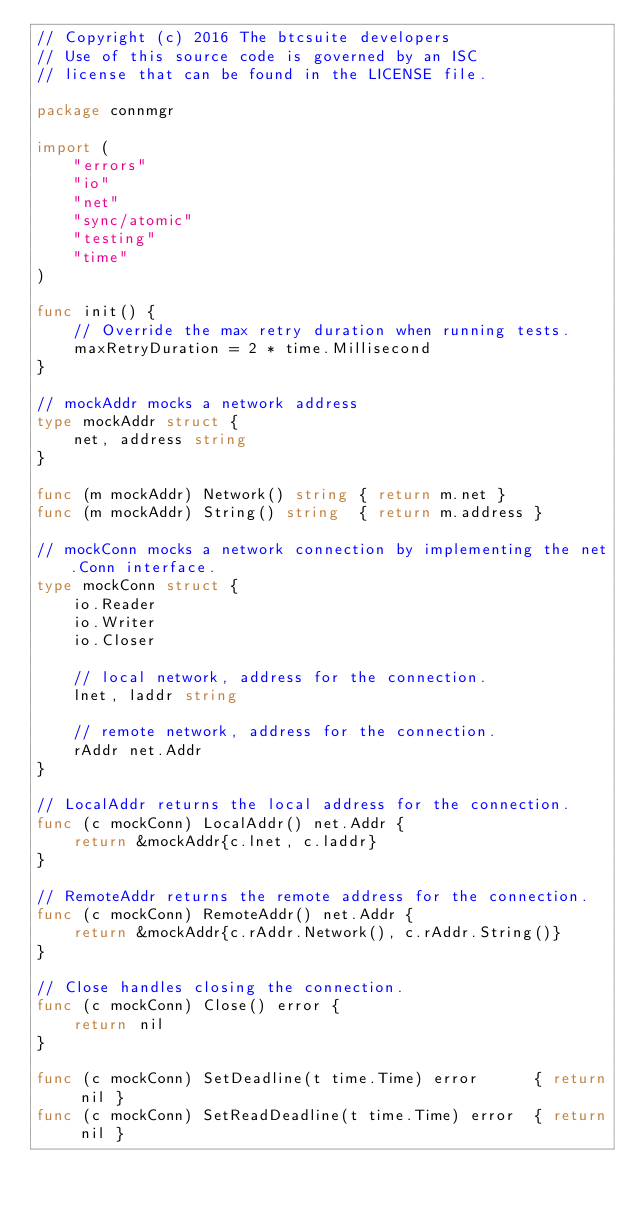<code> <loc_0><loc_0><loc_500><loc_500><_Go_>// Copyright (c) 2016 The btcsuite developers
// Use of this source code is governed by an ISC
// license that can be found in the LICENSE file.

package connmgr

import (
	"errors"
	"io"
	"net"
	"sync/atomic"
	"testing"
	"time"
)

func init() {
	// Override the max retry duration when running tests.
	maxRetryDuration = 2 * time.Millisecond
}

// mockAddr mocks a network address
type mockAddr struct {
	net, address string
}

func (m mockAddr) Network() string { return m.net }
func (m mockAddr) String() string  { return m.address }

// mockConn mocks a network connection by implementing the net.Conn interface.
type mockConn struct {
	io.Reader
	io.Writer
	io.Closer

	// local network, address for the connection.
	lnet, laddr string

	// remote network, address for the connection.
	rAddr net.Addr
}

// LocalAddr returns the local address for the connection.
func (c mockConn) LocalAddr() net.Addr {
	return &mockAddr{c.lnet, c.laddr}
}

// RemoteAddr returns the remote address for the connection.
func (c mockConn) RemoteAddr() net.Addr {
	return &mockAddr{c.rAddr.Network(), c.rAddr.String()}
}

// Close handles closing the connection.
func (c mockConn) Close() error {
	return nil
}

func (c mockConn) SetDeadline(t time.Time) error      { return nil }
func (c mockConn) SetReadDeadline(t time.Time) error  { return nil }</code> 